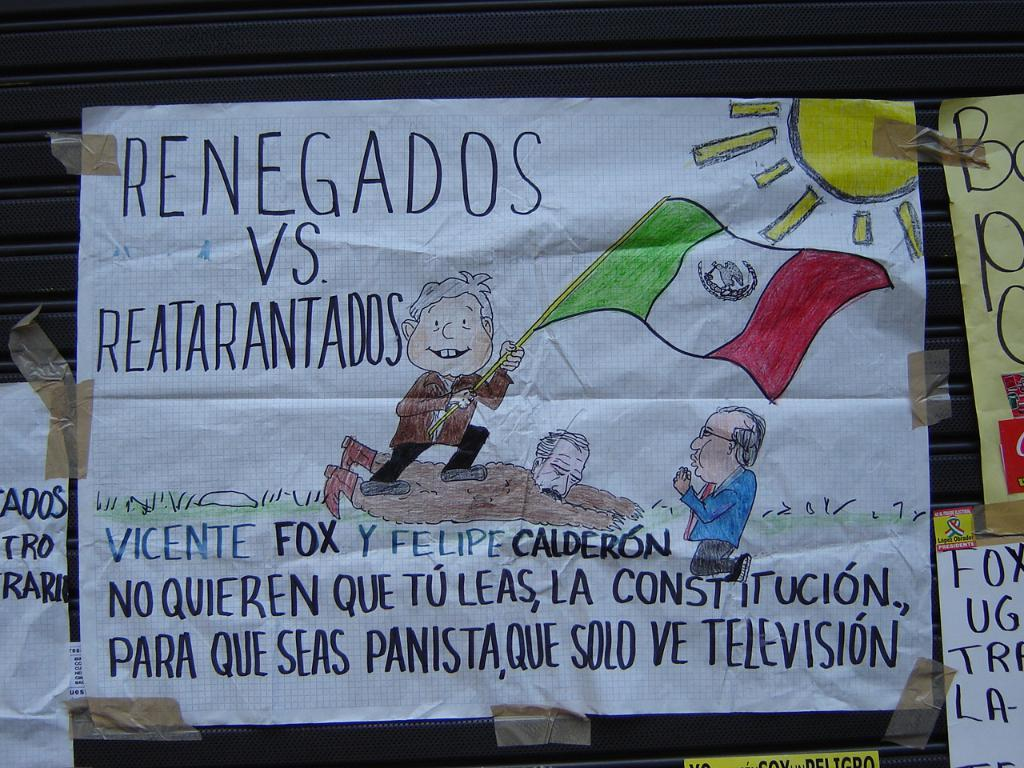Provide a one-sentence caption for the provided image. A hand made sign that is written in Spanish and references Renegados vs. Reatarantados. 